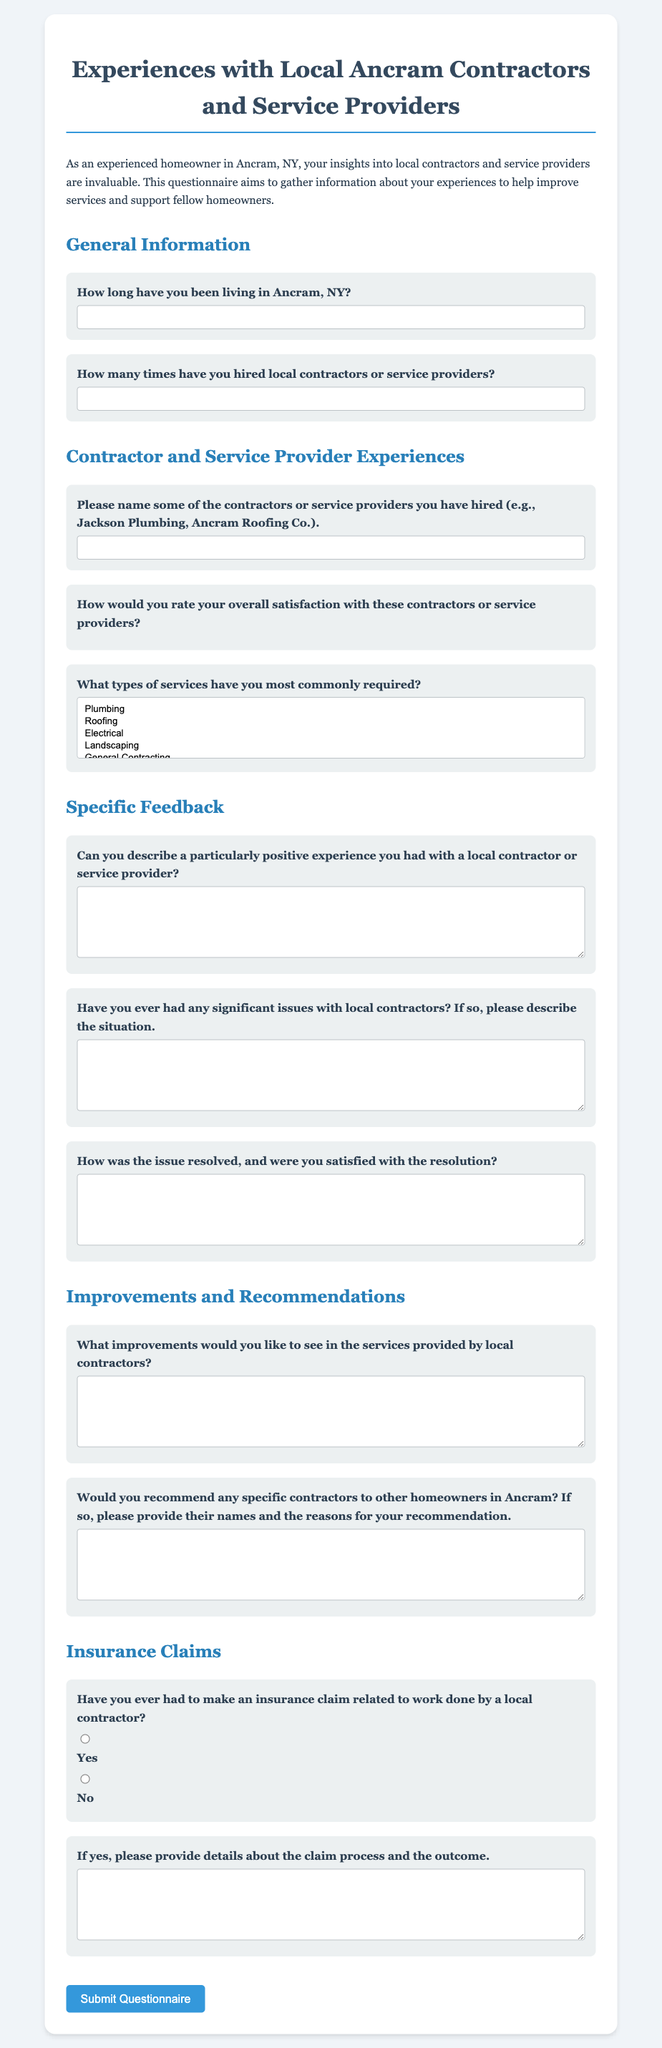What is the title of the questionnaire? The title of the questionnaire is presented prominently at the top, indicating the focus on experiences with local contractors.
Answer: Experiences with Local Ancram Contractors and Service Providers How long should respondents indicate they have lived in Ancram? Respondents are asked for their duration of residency in Ancram in the specific section of the questionnaire.
Answer: How long have you been living in Ancram, NY? What type of service has the option to be selected multiple times? The questionnaire allows respondents to choose from different service types, and it specifies that multiple selections are allowed.
Answer: Services provided by local contractors What is the minimum number of contractors that respondents can list? The form requires at least one contractor's name to be provided, as stated in the corresponding field.
Answer: One contractor Is there a section specifically addressing improvements for contractors? The document includes a dedicated section asking for suggestions on improvements in contractor services.
Answer: Yes, there is a section for improvements What must be described if an insurance claim has been made? If respondents answer that they have made an insurance claim, they have to provide specific details regarding that claim.
Answer: Details about the claim process and outcome How are the contractor rating options structured? The rating options are displayed as a set of five stars that can be selected based on satisfaction level.
Answer: Five stars What is a required component of feedback on positive experiences? Respondents must provide a descriptive account of a particularly positive experience with a contractor.
Answer: Description of a positive experience 